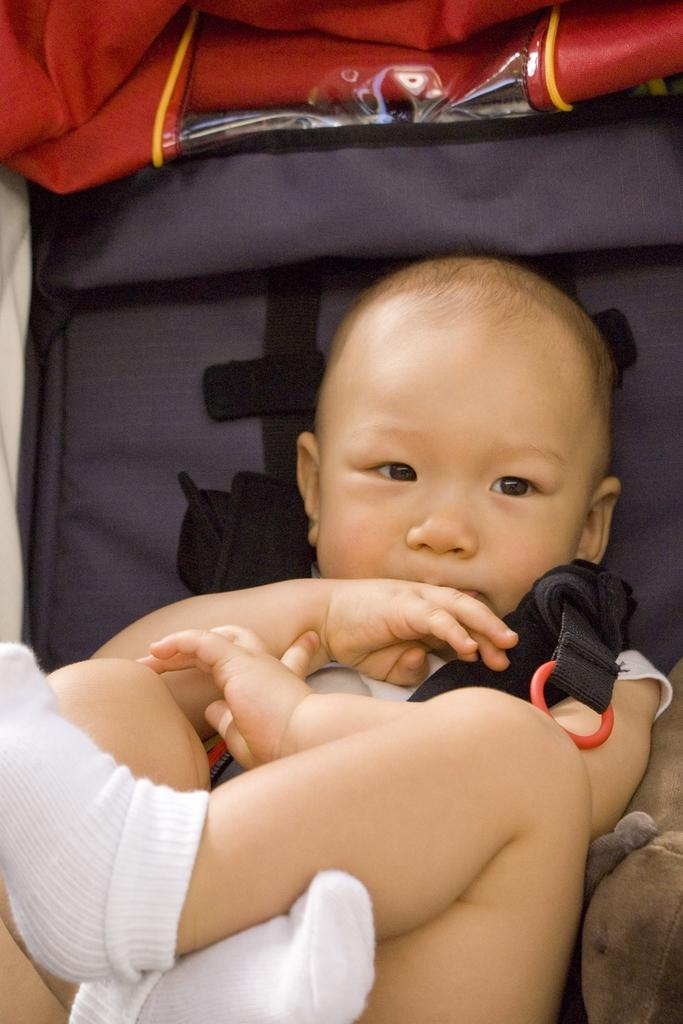What is the main subject of the image? The main subject of the image is a baby. Where is the baby located in the image? The baby is on a stroller. What is the baby wearing in the image? The baby is wearing belts. What else is present in the image related to the stroller? There are belts for the stroller. Can you tell me how many chains are attached to the baby in the image? There are no chains attached to the baby in the image. What type of net is used to cover the baby in the image? There is no net present in the image; the baby is on a stroller and wearing belts. 